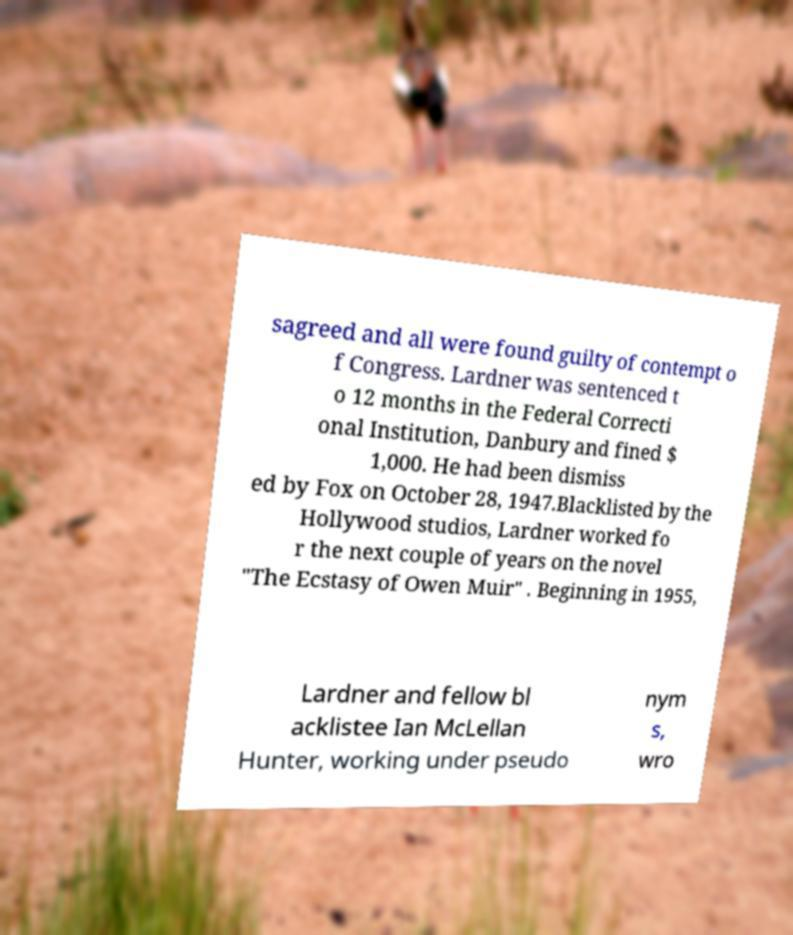There's text embedded in this image that I need extracted. Can you transcribe it verbatim? sagreed and all were found guilty of contempt o f Congress. Lardner was sentenced t o 12 months in the Federal Correcti onal Institution, Danbury and fined $ 1,000. He had been dismiss ed by Fox on October 28, 1947.Blacklisted by the Hollywood studios, Lardner worked fo r the next couple of years on the novel "The Ecstasy of Owen Muir" . Beginning in 1955, Lardner and fellow bl acklistee Ian McLellan Hunter, working under pseudo nym s, wro 